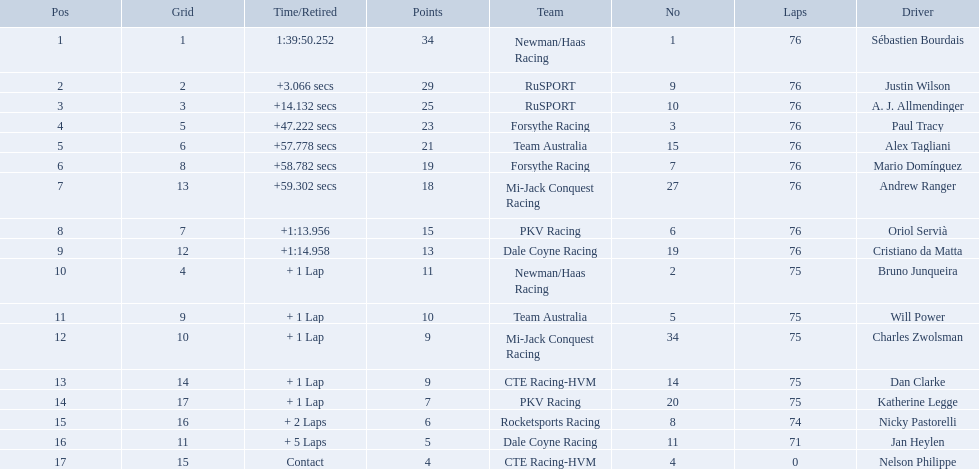What drivers took part in the 2006 tecate grand prix of monterrey? Sébastien Bourdais, Justin Wilson, A. J. Allmendinger, Paul Tracy, Alex Tagliani, Mario Domínguez, Andrew Ranger, Oriol Servià, Cristiano da Matta, Bruno Junqueira, Will Power, Charles Zwolsman, Dan Clarke, Katherine Legge, Nicky Pastorelli, Jan Heylen, Nelson Philippe. Which of those drivers scored the same amount of points as another driver? Charles Zwolsman, Dan Clarke. Who had the same amount of points as charles zwolsman? Dan Clarke. 